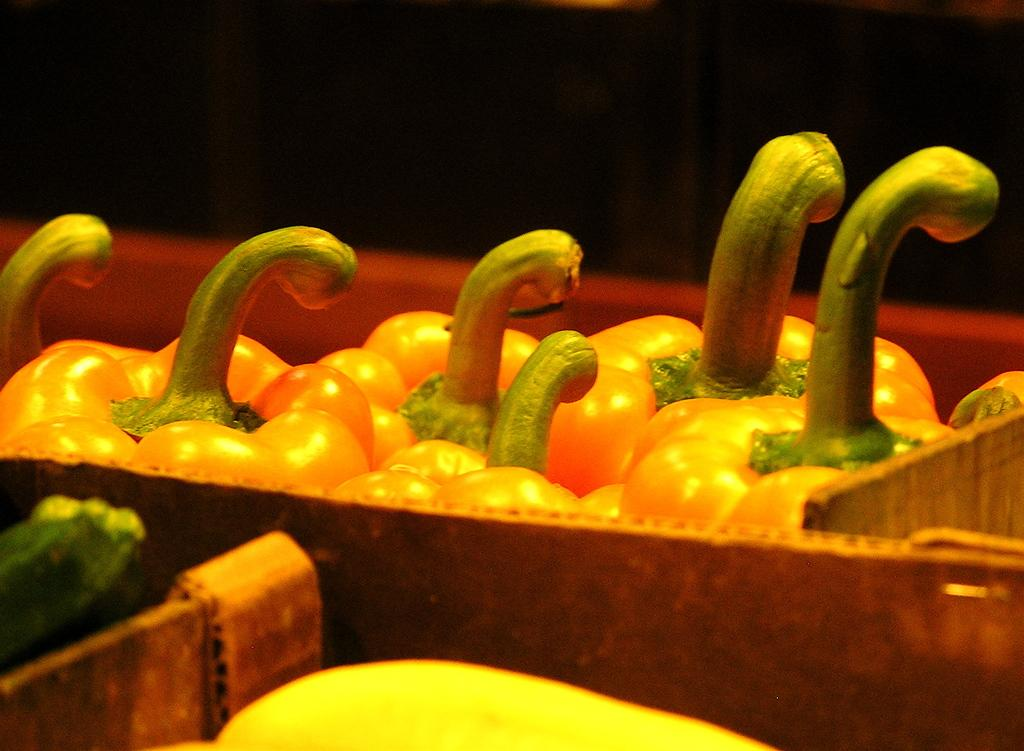What type of vegetables are in the image? There are capsicums in the image. What color are the capsicums? The capsicums are in orange color. How are the capsicums arranged in the image? The capsicums are placed in a wooden basket. What can be observed about the background of the image? The background of the image is dark. What type of bird can be seen flying in the image? There is no bird present in the image; it features capsicums in a wooden basket with a dark background. 